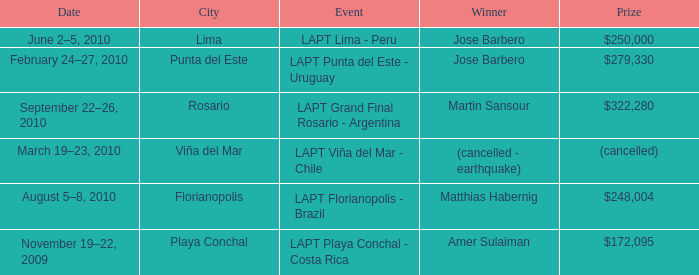What event is in florianopolis? LAPT Florianopolis - Brazil. 